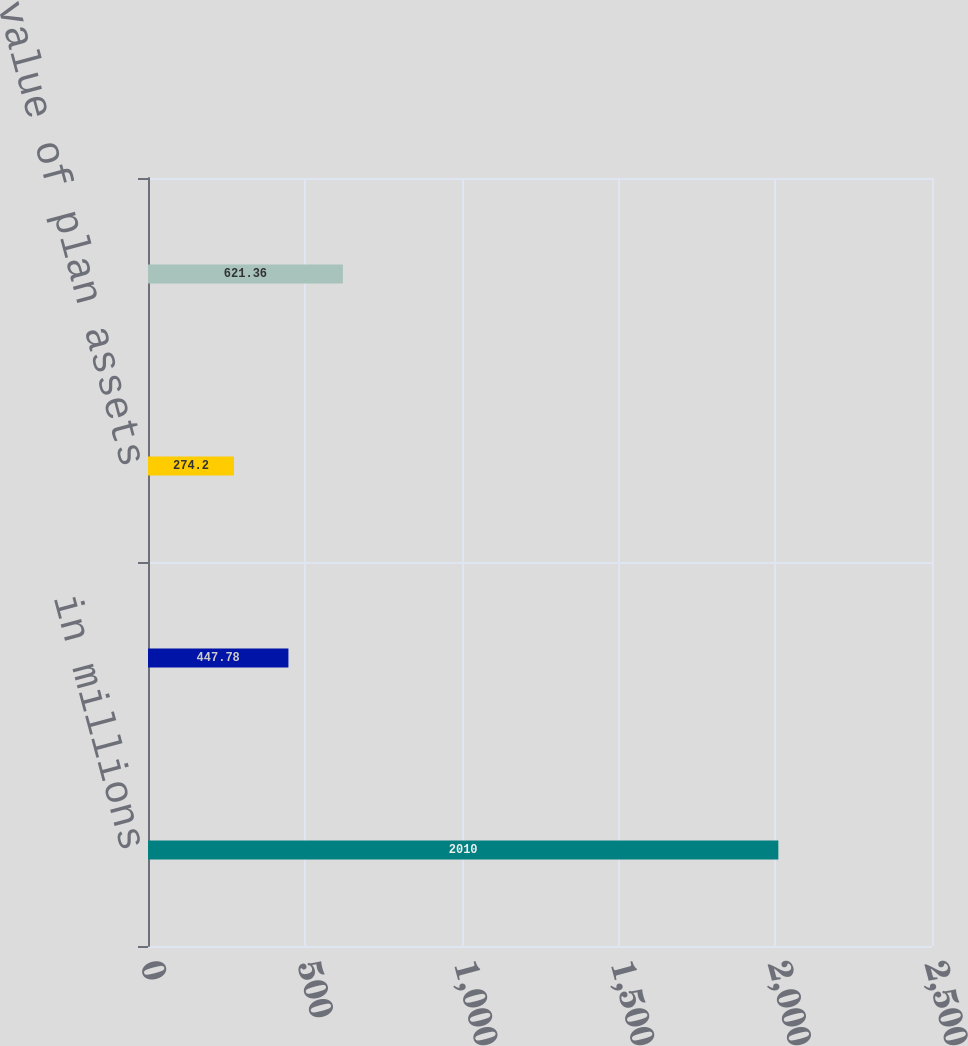<chart> <loc_0><loc_0><loc_500><loc_500><bar_chart><fcel>in millions<fcel>Accumulated benefit obligation<fcel>Fair value of plan assets<fcel>Projected benefit obligation<nl><fcel>2010<fcel>447.78<fcel>274.2<fcel>621.36<nl></chart> 